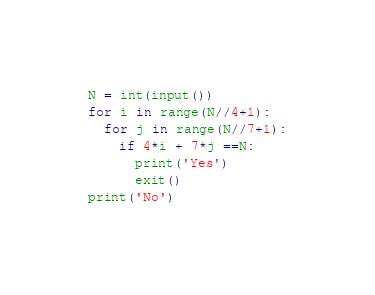<code> <loc_0><loc_0><loc_500><loc_500><_Python_>N = int(input())
for i in range(N//4+1):
  for j in range(N//7+1):
    if 4*i + 7*j ==N:
      print('Yes')
      exit()
print('No')</code> 